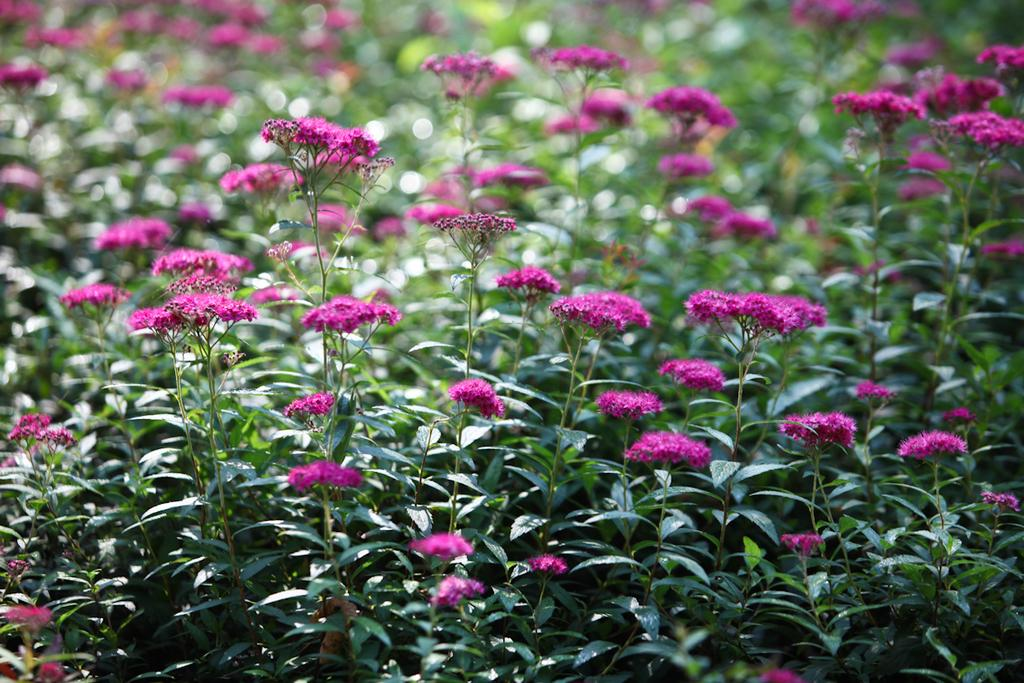What type of living organisms can be seen in the image? There are flowers and plants visible in the image. Can you describe the plants in the image? The plants in the image are not specified, but they are present alongside the flowers. How many chickens are present in the image? There are no chickens present in the image; it only features flowers and plants. Is there a squirrel visible in the image? There is no squirrel present in the image; it only features flowers and plants. 